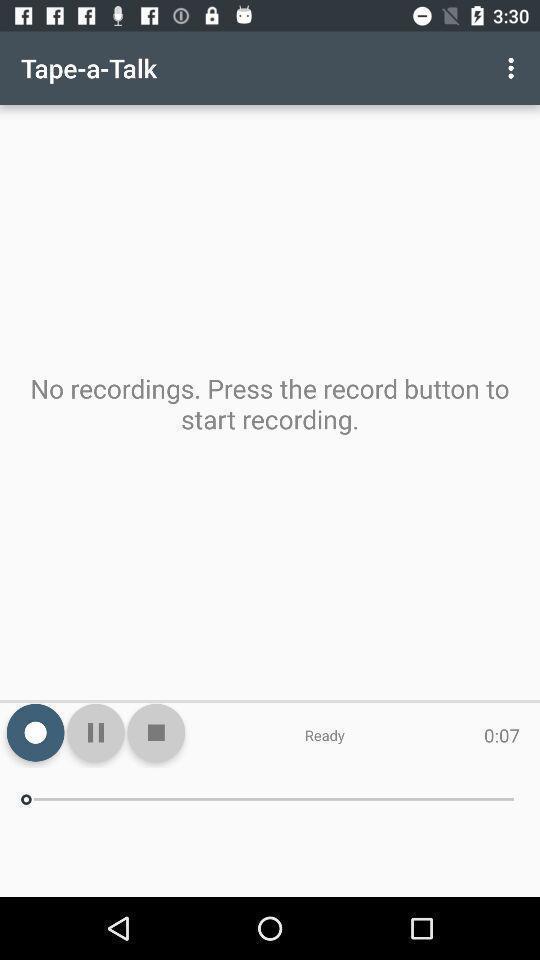Tell me what you see in this picture. Screen shows a page to tape recorder. 